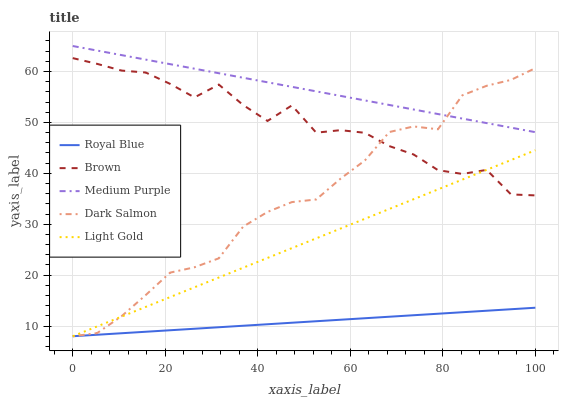Does Light Gold have the minimum area under the curve?
Answer yes or no. No. Does Light Gold have the maximum area under the curve?
Answer yes or no. No. Is Light Gold the smoothest?
Answer yes or no. No. Is Light Gold the roughest?
Answer yes or no. No. Does Brown have the lowest value?
Answer yes or no. No. Does Light Gold have the highest value?
Answer yes or no. No. Is Brown less than Medium Purple?
Answer yes or no. Yes. Is Medium Purple greater than Brown?
Answer yes or no. Yes. Does Brown intersect Medium Purple?
Answer yes or no. No. 